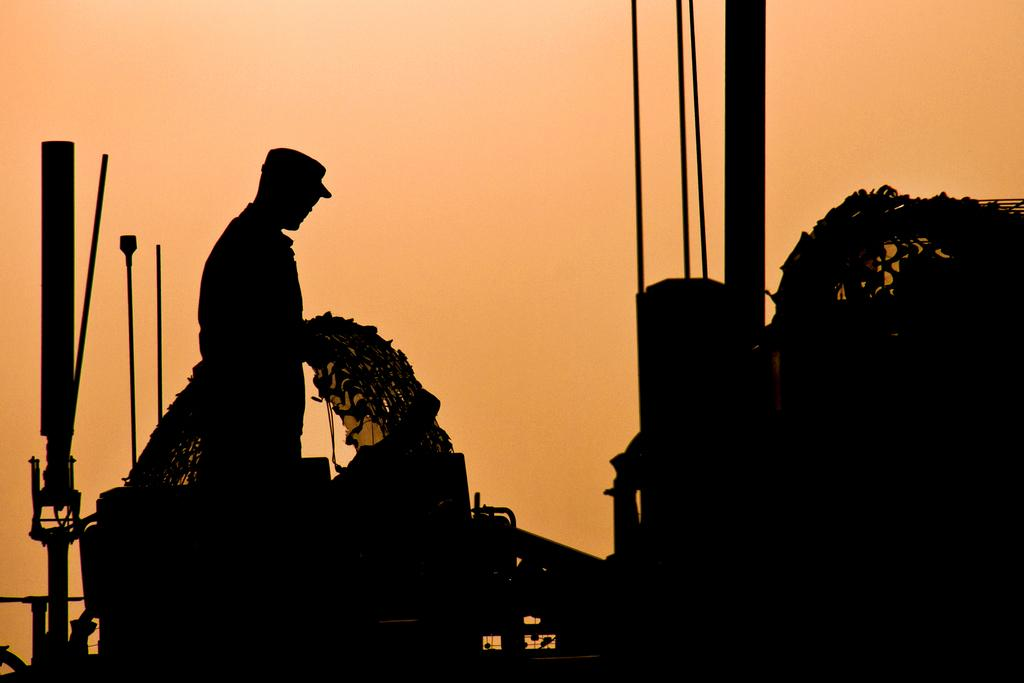What is the main subject of the image? There is a person standing in the image. What is the person holding in the image? The person is holding an object. What type of structures can be seen in the image? There are poles and rods in the image. What is visible in the background of the image? The sky is visible in the image. What scientific discovery is the person making in the image? There is no indication of a scientific discovery being made in the image. What impulse is driving the person's actions in the image? The facts provided do not give any information about the person's motivation or impulse. 